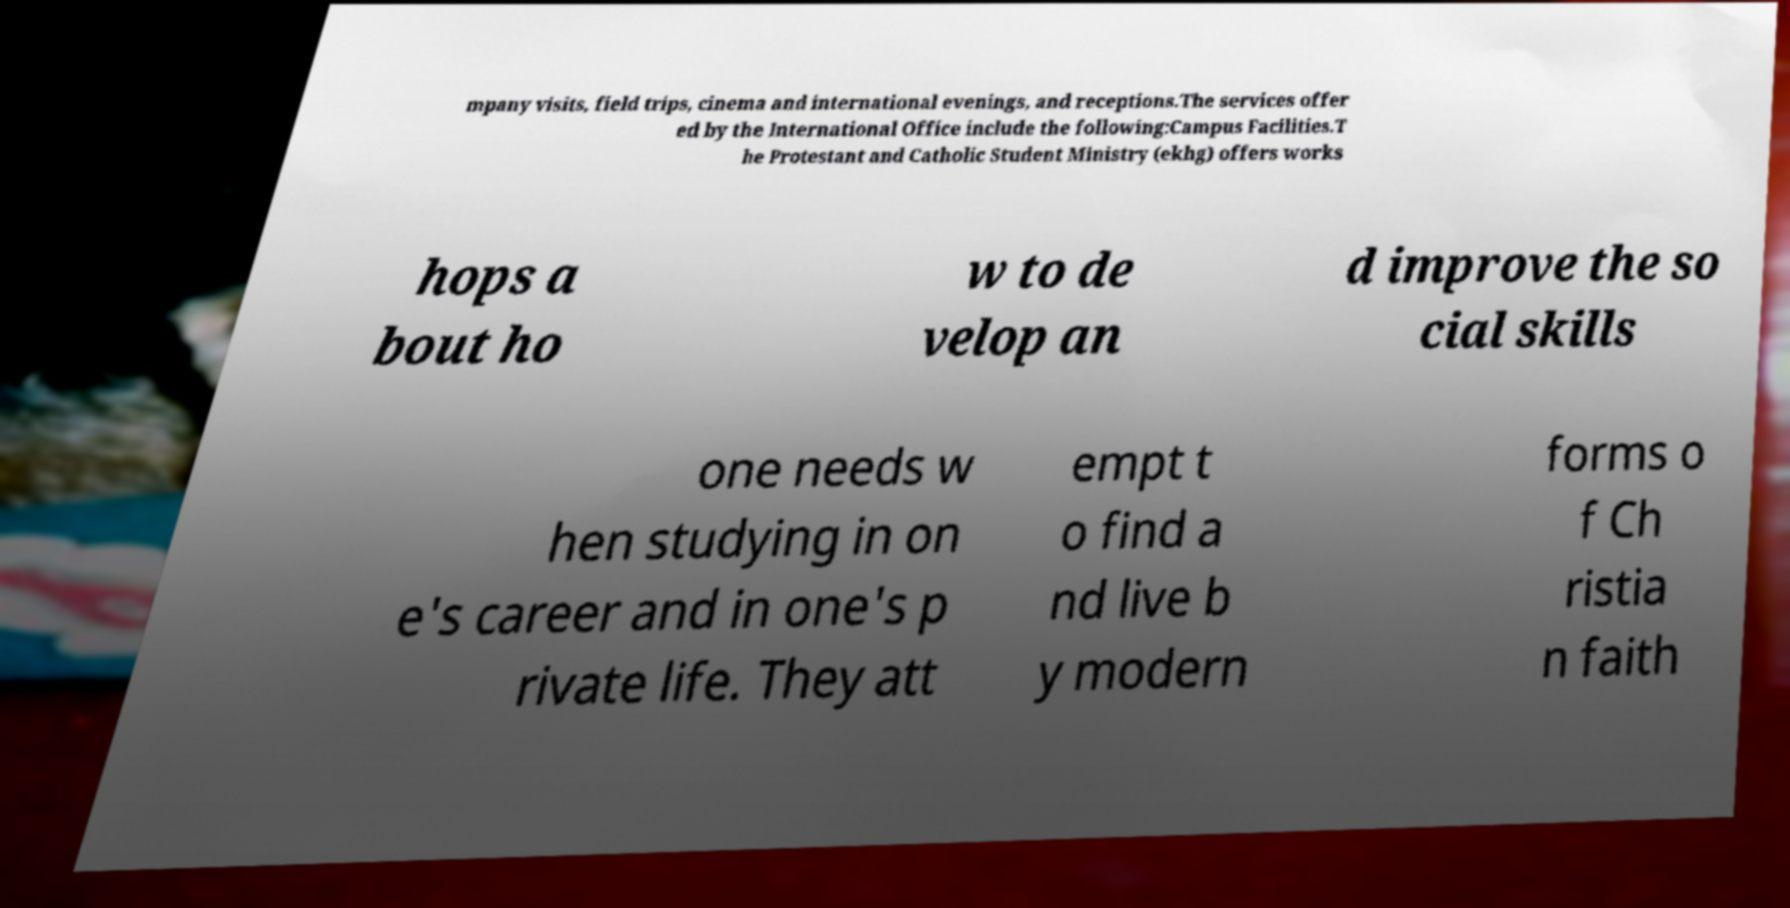Can you read and provide the text displayed in the image?This photo seems to have some interesting text. Can you extract and type it out for me? mpany visits, field trips, cinema and international evenings, and receptions.The services offer ed by the International Office include the following:Campus Facilities.T he Protestant and Catholic Student Ministry (ekhg) offers works hops a bout ho w to de velop an d improve the so cial skills one needs w hen studying in on e's career and in one's p rivate life. They att empt t o find a nd live b y modern forms o f Ch ristia n faith 